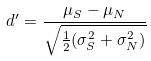<formula> <loc_0><loc_0><loc_500><loc_500>d ^ { \prime } = \frac { \mu _ { S } - \mu _ { N } } { \sqrt { \frac { 1 } { 2 } ( \sigma _ { S } ^ { 2 } + \sigma _ { N } ^ { 2 } ) } }</formula> 